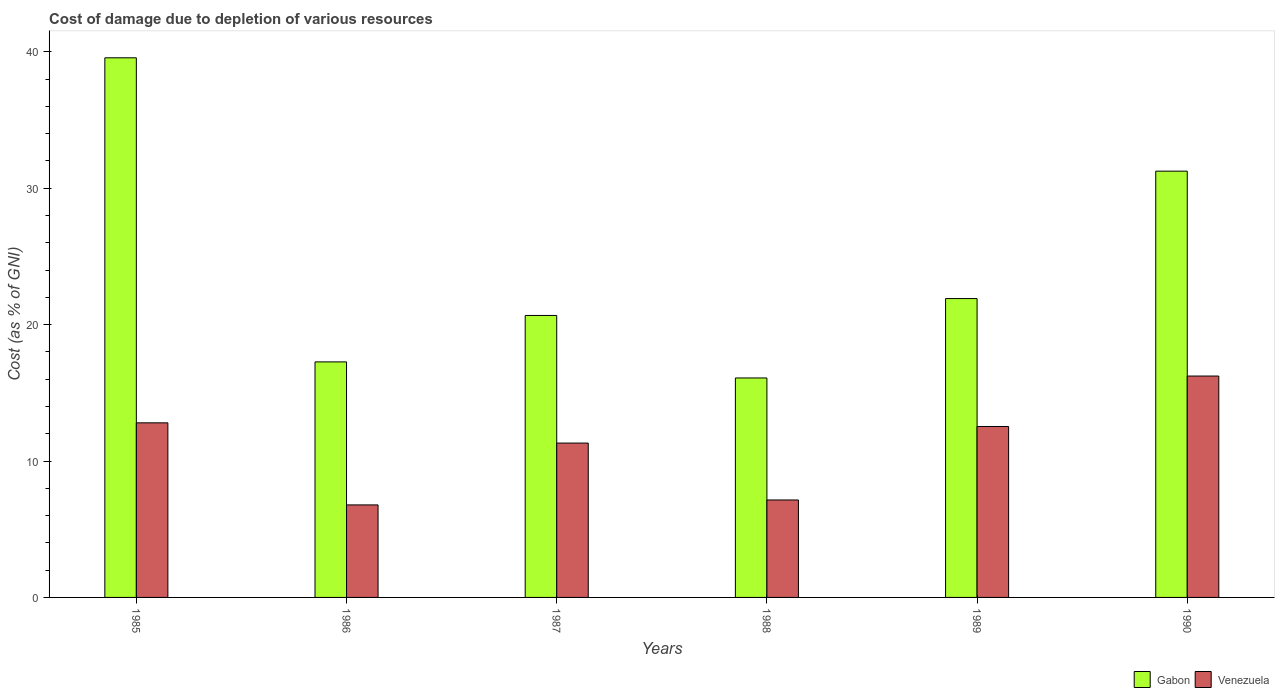How many different coloured bars are there?
Your answer should be very brief. 2. Are the number of bars per tick equal to the number of legend labels?
Make the answer very short. Yes. How many bars are there on the 4th tick from the left?
Your answer should be compact. 2. How many bars are there on the 2nd tick from the right?
Keep it short and to the point. 2. In how many cases, is the number of bars for a given year not equal to the number of legend labels?
Your response must be concise. 0. What is the cost of damage caused due to the depletion of various resources in Venezuela in 1988?
Offer a very short reply. 7.14. Across all years, what is the maximum cost of damage caused due to the depletion of various resources in Gabon?
Make the answer very short. 39.56. Across all years, what is the minimum cost of damage caused due to the depletion of various resources in Venezuela?
Your answer should be very brief. 6.78. In which year was the cost of damage caused due to the depletion of various resources in Venezuela maximum?
Your answer should be very brief. 1990. In which year was the cost of damage caused due to the depletion of various resources in Gabon minimum?
Provide a short and direct response. 1988. What is the total cost of damage caused due to the depletion of various resources in Gabon in the graph?
Ensure brevity in your answer.  146.73. What is the difference between the cost of damage caused due to the depletion of various resources in Venezuela in 1986 and that in 1988?
Your answer should be compact. -0.36. What is the difference between the cost of damage caused due to the depletion of various resources in Venezuela in 1988 and the cost of damage caused due to the depletion of various resources in Gabon in 1985?
Make the answer very short. -32.41. What is the average cost of damage caused due to the depletion of various resources in Gabon per year?
Give a very brief answer. 24.46. In the year 1986, what is the difference between the cost of damage caused due to the depletion of various resources in Gabon and cost of damage caused due to the depletion of various resources in Venezuela?
Give a very brief answer. 10.48. What is the ratio of the cost of damage caused due to the depletion of various resources in Venezuela in 1987 to that in 1989?
Give a very brief answer. 0.9. Is the difference between the cost of damage caused due to the depletion of various resources in Gabon in 1987 and 1989 greater than the difference between the cost of damage caused due to the depletion of various resources in Venezuela in 1987 and 1989?
Offer a terse response. No. What is the difference between the highest and the second highest cost of damage caused due to the depletion of various resources in Gabon?
Make the answer very short. 8.31. What is the difference between the highest and the lowest cost of damage caused due to the depletion of various resources in Venezuela?
Make the answer very short. 9.45. What does the 2nd bar from the left in 1987 represents?
Offer a terse response. Venezuela. What does the 1st bar from the right in 1989 represents?
Offer a very short reply. Venezuela. How many bars are there?
Make the answer very short. 12. What is the difference between two consecutive major ticks on the Y-axis?
Provide a short and direct response. 10. Are the values on the major ticks of Y-axis written in scientific E-notation?
Provide a short and direct response. No. Does the graph contain grids?
Make the answer very short. No. Where does the legend appear in the graph?
Offer a very short reply. Bottom right. How many legend labels are there?
Keep it short and to the point. 2. How are the legend labels stacked?
Your answer should be compact. Horizontal. What is the title of the graph?
Offer a very short reply. Cost of damage due to depletion of various resources. What is the label or title of the Y-axis?
Your answer should be very brief. Cost (as % of GNI). What is the Cost (as % of GNI) of Gabon in 1985?
Give a very brief answer. 39.56. What is the Cost (as % of GNI) in Venezuela in 1985?
Offer a very short reply. 12.8. What is the Cost (as % of GNI) of Gabon in 1986?
Offer a terse response. 17.27. What is the Cost (as % of GNI) in Venezuela in 1986?
Your answer should be very brief. 6.78. What is the Cost (as % of GNI) of Gabon in 1987?
Offer a terse response. 20.67. What is the Cost (as % of GNI) of Venezuela in 1987?
Your answer should be compact. 11.32. What is the Cost (as % of GNI) in Gabon in 1988?
Ensure brevity in your answer.  16.09. What is the Cost (as % of GNI) in Venezuela in 1988?
Ensure brevity in your answer.  7.14. What is the Cost (as % of GNI) of Gabon in 1989?
Provide a succinct answer. 21.91. What is the Cost (as % of GNI) in Venezuela in 1989?
Your answer should be compact. 12.53. What is the Cost (as % of GNI) of Gabon in 1990?
Keep it short and to the point. 31.25. What is the Cost (as % of GNI) of Venezuela in 1990?
Make the answer very short. 16.23. Across all years, what is the maximum Cost (as % of GNI) of Gabon?
Give a very brief answer. 39.56. Across all years, what is the maximum Cost (as % of GNI) in Venezuela?
Offer a terse response. 16.23. Across all years, what is the minimum Cost (as % of GNI) of Gabon?
Ensure brevity in your answer.  16.09. Across all years, what is the minimum Cost (as % of GNI) in Venezuela?
Your response must be concise. 6.78. What is the total Cost (as % of GNI) in Gabon in the graph?
Provide a succinct answer. 146.73. What is the total Cost (as % of GNI) of Venezuela in the graph?
Give a very brief answer. 66.8. What is the difference between the Cost (as % of GNI) of Gabon in 1985 and that in 1986?
Your answer should be very brief. 22.29. What is the difference between the Cost (as % of GNI) of Venezuela in 1985 and that in 1986?
Your answer should be compact. 6.02. What is the difference between the Cost (as % of GNI) of Gabon in 1985 and that in 1987?
Provide a succinct answer. 18.89. What is the difference between the Cost (as % of GNI) of Venezuela in 1985 and that in 1987?
Provide a short and direct response. 1.48. What is the difference between the Cost (as % of GNI) of Gabon in 1985 and that in 1988?
Keep it short and to the point. 23.47. What is the difference between the Cost (as % of GNI) of Venezuela in 1985 and that in 1988?
Offer a terse response. 5.65. What is the difference between the Cost (as % of GNI) of Gabon in 1985 and that in 1989?
Provide a succinct answer. 17.65. What is the difference between the Cost (as % of GNI) in Venezuela in 1985 and that in 1989?
Ensure brevity in your answer.  0.27. What is the difference between the Cost (as % of GNI) of Gabon in 1985 and that in 1990?
Keep it short and to the point. 8.31. What is the difference between the Cost (as % of GNI) of Venezuela in 1985 and that in 1990?
Give a very brief answer. -3.43. What is the difference between the Cost (as % of GNI) in Gabon in 1986 and that in 1987?
Provide a short and direct response. -3.4. What is the difference between the Cost (as % of GNI) in Venezuela in 1986 and that in 1987?
Provide a short and direct response. -4.53. What is the difference between the Cost (as % of GNI) in Gabon in 1986 and that in 1988?
Provide a succinct answer. 1.18. What is the difference between the Cost (as % of GNI) in Venezuela in 1986 and that in 1988?
Offer a very short reply. -0.36. What is the difference between the Cost (as % of GNI) of Gabon in 1986 and that in 1989?
Give a very brief answer. -4.64. What is the difference between the Cost (as % of GNI) in Venezuela in 1986 and that in 1989?
Make the answer very short. -5.75. What is the difference between the Cost (as % of GNI) of Gabon in 1986 and that in 1990?
Your response must be concise. -13.98. What is the difference between the Cost (as % of GNI) of Venezuela in 1986 and that in 1990?
Give a very brief answer. -9.45. What is the difference between the Cost (as % of GNI) of Gabon in 1987 and that in 1988?
Your response must be concise. 4.58. What is the difference between the Cost (as % of GNI) of Venezuela in 1987 and that in 1988?
Give a very brief answer. 4.17. What is the difference between the Cost (as % of GNI) of Gabon in 1987 and that in 1989?
Make the answer very short. -1.24. What is the difference between the Cost (as % of GNI) in Venezuela in 1987 and that in 1989?
Your answer should be compact. -1.21. What is the difference between the Cost (as % of GNI) in Gabon in 1987 and that in 1990?
Ensure brevity in your answer.  -10.58. What is the difference between the Cost (as % of GNI) of Venezuela in 1987 and that in 1990?
Your response must be concise. -4.91. What is the difference between the Cost (as % of GNI) in Gabon in 1988 and that in 1989?
Offer a very short reply. -5.82. What is the difference between the Cost (as % of GNI) of Venezuela in 1988 and that in 1989?
Offer a terse response. -5.39. What is the difference between the Cost (as % of GNI) in Gabon in 1988 and that in 1990?
Make the answer very short. -15.16. What is the difference between the Cost (as % of GNI) in Venezuela in 1988 and that in 1990?
Give a very brief answer. -9.08. What is the difference between the Cost (as % of GNI) in Gabon in 1989 and that in 1990?
Offer a very short reply. -9.34. What is the difference between the Cost (as % of GNI) of Venezuela in 1989 and that in 1990?
Provide a succinct answer. -3.7. What is the difference between the Cost (as % of GNI) in Gabon in 1985 and the Cost (as % of GNI) in Venezuela in 1986?
Provide a succinct answer. 32.77. What is the difference between the Cost (as % of GNI) in Gabon in 1985 and the Cost (as % of GNI) in Venezuela in 1987?
Your response must be concise. 28.24. What is the difference between the Cost (as % of GNI) of Gabon in 1985 and the Cost (as % of GNI) of Venezuela in 1988?
Your response must be concise. 32.41. What is the difference between the Cost (as % of GNI) of Gabon in 1985 and the Cost (as % of GNI) of Venezuela in 1989?
Provide a short and direct response. 27.03. What is the difference between the Cost (as % of GNI) of Gabon in 1985 and the Cost (as % of GNI) of Venezuela in 1990?
Give a very brief answer. 23.33. What is the difference between the Cost (as % of GNI) of Gabon in 1986 and the Cost (as % of GNI) of Venezuela in 1987?
Make the answer very short. 5.95. What is the difference between the Cost (as % of GNI) of Gabon in 1986 and the Cost (as % of GNI) of Venezuela in 1988?
Ensure brevity in your answer.  10.12. What is the difference between the Cost (as % of GNI) of Gabon in 1986 and the Cost (as % of GNI) of Venezuela in 1989?
Provide a succinct answer. 4.74. What is the difference between the Cost (as % of GNI) in Gabon in 1986 and the Cost (as % of GNI) in Venezuela in 1990?
Give a very brief answer. 1.04. What is the difference between the Cost (as % of GNI) in Gabon in 1987 and the Cost (as % of GNI) in Venezuela in 1988?
Offer a very short reply. 13.53. What is the difference between the Cost (as % of GNI) in Gabon in 1987 and the Cost (as % of GNI) in Venezuela in 1989?
Make the answer very short. 8.14. What is the difference between the Cost (as % of GNI) in Gabon in 1987 and the Cost (as % of GNI) in Venezuela in 1990?
Your response must be concise. 4.44. What is the difference between the Cost (as % of GNI) of Gabon in 1988 and the Cost (as % of GNI) of Venezuela in 1989?
Provide a short and direct response. 3.56. What is the difference between the Cost (as % of GNI) of Gabon in 1988 and the Cost (as % of GNI) of Venezuela in 1990?
Offer a very short reply. -0.14. What is the difference between the Cost (as % of GNI) in Gabon in 1989 and the Cost (as % of GNI) in Venezuela in 1990?
Offer a terse response. 5.68. What is the average Cost (as % of GNI) of Gabon per year?
Your answer should be compact. 24.46. What is the average Cost (as % of GNI) in Venezuela per year?
Ensure brevity in your answer.  11.13. In the year 1985, what is the difference between the Cost (as % of GNI) of Gabon and Cost (as % of GNI) of Venezuela?
Provide a short and direct response. 26.76. In the year 1986, what is the difference between the Cost (as % of GNI) in Gabon and Cost (as % of GNI) in Venezuela?
Ensure brevity in your answer.  10.48. In the year 1987, what is the difference between the Cost (as % of GNI) of Gabon and Cost (as % of GNI) of Venezuela?
Keep it short and to the point. 9.35. In the year 1988, what is the difference between the Cost (as % of GNI) of Gabon and Cost (as % of GNI) of Venezuela?
Ensure brevity in your answer.  8.94. In the year 1989, what is the difference between the Cost (as % of GNI) of Gabon and Cost (as % of GNI) of Venezuela?
Offer a very short reply. 9.38. In the year 1990, what is the difference between the Cost (as % of GNI) of Gabon and Cost (as % of GNI) of Venezuela?
Provide a succinct answer. 15.02. What is the ratio of the Cost (as % of GNI) in Gabon in 1985 to that in 1986?
Your answer should be compact. 2.29. What is the ratio of the Cost (as % of GNI) in Venezuela in 1985 to that in 1986?
Make the answer very short. 1.89. What is the ratio of the Cost (as % of GNI) of Gabon in 1985 to that in 1987?
Offer a terse response. 1.91. What is the ratio of the Cost (as % of GNI) of Venezuela in 1985 to that in 1987?
Provide a short and direct response. 1.13. What is the ratio of the Cost (as % of GNI) in Gabon in 1985 to that in 1988?
Your answer should be very brief. 2.46. What is the ratio of the Cost (as % of GNI) of Venezuela in 1985 to that in 1988?
Your response must be concise. 1.79. What is the ratio of the Cost (as % of GNI) of Gabon in 1985 to that in 1989?
Give a very brief answer. 1.81. What is the ratio of the Cost (as % of GNI) of Venezuela in 1985 to that in 1989?
Your answer should be very brief. 1.02. What is the ratio of the Cost (as % of GNI) of Gabon in 1985 to that in 1990?
Make the answer very short. 1.27. What is the ratio of the Cost (as % of GNI) in Venezuela in 1985 to that in 1990?
Your answer should be very brief. 0.79. What is the ratio of the Cost (as % of GNI) of Gabon in 1986 to that in 1987?
Make the answer very short. 0.84. What is the ratio of the Cost (as % of GNI) in Venezuela in 1986 to that in 1987?
Ensure brevity in your answer.  0.6. What is the ratio of the Cost (as % of GNI) in Gabon in 1986 to that in 1988?
Your answer should be compact. 1.07. What is the ratio of the Cost (as % of GNI) in Venezuela in 1986 to that in 1988?
Your answer should be very brief. 0.95. What is the ratio of the Cost (as % of GNI) of Gabon in 1986 to that in 1989?
Your answer should be compact. 0.79. What is the ratio of the Cost (as % of GNI) of Venezuela in 1986 to that in 1989?
Provide a short and direct response. 0.54. What is the ratio of the Cost (as % of GNI) of Gabon in 1986 to that in 1990?
Keep it short and to the point. 0.55. What is the ratio of the Cost (as % of GNI) in Venezuela in 1986 to that in 1990?
Keep it short and to the point. 0.42. What is the ratio of the Cost (as % of GNI) in Gabon in 1987 to that in 1988?
Offer a very short reply. 1.28. What is the ratio of the Cost (as % of GNI) in Venezuela in 1987 to that in 1988?
Make the answer very short. 1.58. What is the ratio of the Cost (as % of GNI) of Gabon in 1987 to that in 1989?
Ensure brevity in your answer.  0.94. What is the ratio of the Cost (as % of GNI) of Venezuela in 1987 to that in 1989?
Provide a short and direct response. 0.9. What is the ratio of the Cost (as % of GNI) of Gabon in 1987 to that in 1990?
Your answer should be very brief. 0.66. What is the ratio of the Cost (as % of GNI) in Venezuela in 1987 to that in 1990?
Offer a very short reply. 0.7. What is the ratio of the Cost (as % of GNI) of Gabon in 1988 to that in 1989?
Your response must be concise. 0.73. What is the ratio of the Cost (as % of GNI) in Venezuela in 1988 to that in 1989?
Ensure brevity in your answer.  0.57. What is the ratio of the Cost (as % of GNI) of Gabon in 1988 to that in 1990?
Your response must be concise. 0.51. What is the ratio of the Cost (as % of GNI) in Venezuela in 1988 to that in 1990?
Provide a succinct answer. 0.44. What is the ratio of the Cost (as % of GNI) of Gabon in 1989 to that in 1990?
Your answer should be very brief. 0.7. What is the ratio of the Cost (as % of GNI) of Venezuela in 1989 to that in 1990?
Provide a succinct answer. 0.77. What is the difference between the highest and the second highest Cost (as % of GNI) of Gabon?
Give a very brief answer. 8.31. What is the difference between the highest and the second highest Cost (as % of GNI) of Venezuela?
Keep it short and to the point. 3.43. What is the difference between the highest and the lowest Cost (as % of GNI) in Gabon?
Your answer should be very brief. 23.47. What is the difference between the highest and the lowest Cost (as % of GNI) of Venezuela?
Provide a short and direct response. 9.45. 